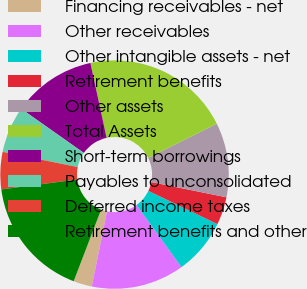<chart> <loc_0><loc_0><loc_500><loc_500><pie_chart><fcel>Financing receivables - net<fcel>Other receivables<fcel>Other intangible assets - net<fcel>Retirement benefits<fcel>Other assets<fcel>Total Assets<fcel>Short-term borrowings<fcel>Payables to unconsolidated<fcel>Deferred income taxes<fcel>Retirement benefits and other<nl><fcel>2.63%<fcel>13.16%<fcel>7.9%<fcel>3.95%<fcel>10.53%<fcel>21.05%<fcel>11.84%<fcel>6.58%<fcel>5.27%<fcel>17.1%<nl></chart> 